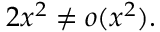Convert formula to latex. <formula><loc_0><loc_0><loc_500><loc_500>2 x ^ { 2 } \neq o ( x ^ { 2 } ) .</formula> 